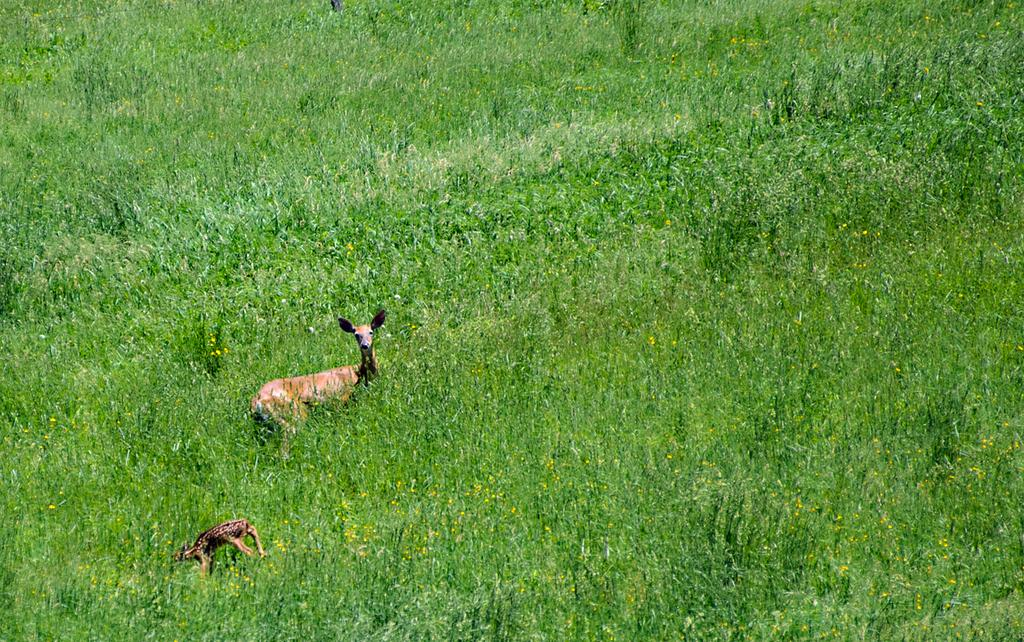What types of living organisms can be seen in the image? There are animals in the image. What can be seen in the background or surrounding the animals? There is greenery in the image. What is the title of the book that the deer is holding in the image? There is no book or deer present in the image. 